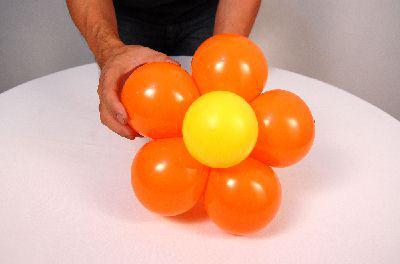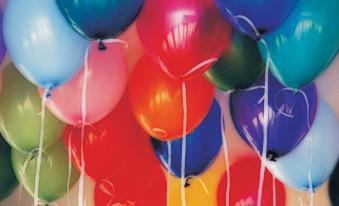The first image is the image on the left, the second image is the image on the right. Considering the images on both sides, is "The left image shows at least four balloons of the same color joined together, and one balloon of a different color." valid? Answer yes or no. Yes. 